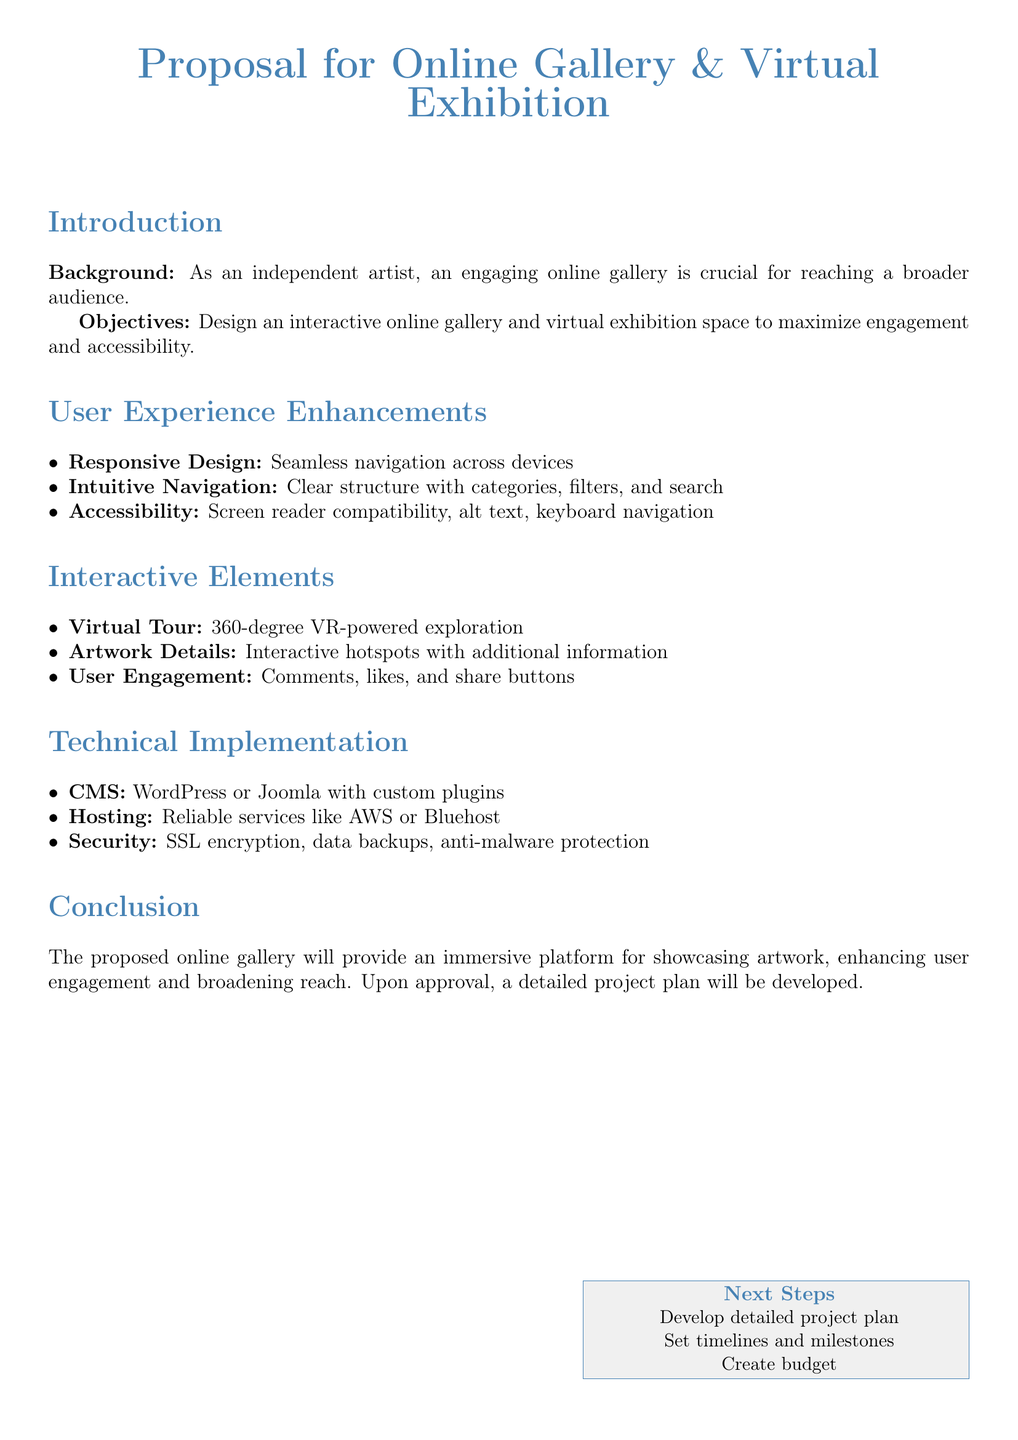What is the main focus of the proposal? The main focus of the proposal is to design an interactive online gallery and virtual exhibition space.
Answer: design an interactive online gallery and virtual exhibition space What platform is suggested for the CMS? The proposal suggests using either WordPress or Joomla for the CMS.
Answer: WordPress or Joomla What type of security is mentioned? The proposal mentions SSL encryption as a part of the security measures.
Answer: SSL encryption What interactive element allows for 360-degree exploration? The virtual tour is the interactive element that allows for 360-degree exploration.
Answer: Virtual Tour How many user experience enhancements are listed? There are three user experience enhancements listed in the document.
Answer: three What will be developed upon approval? A detailed project plan will be developed upon approval.
Answer: detailed project plan What color is used for the main title? The main title is colored artist blue.
Answer: artist blue What is the role of alt text in the proposal? The alt text serves the purpose of providing accessibility within the gallery.
Answer: Accessibility What type of engagement features does the proposal include? The proposal includes comments, likes, and share buttons as engagement features.
Answer: comments, likes, and share buttons 